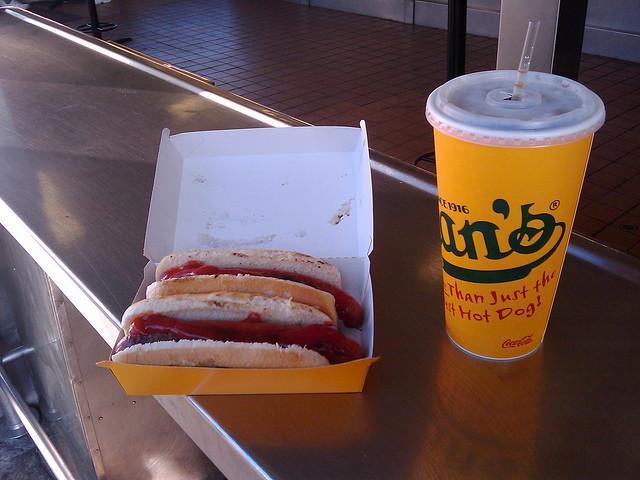How many hot dogs are in the picture?
Give a very brief answer. 2. 